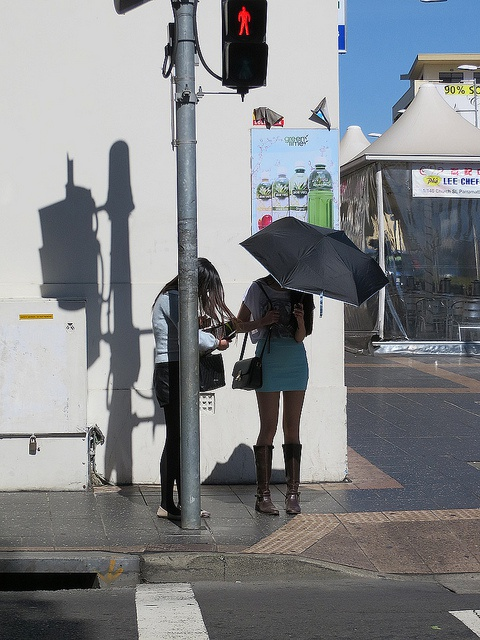Describe the objects in this image and their specific colors. I can see people in lightgray, black, blue, and darkblue tones, people in lightgray, black, gray, and darkgray tones, umbrella in lightgray, black, and gray tones, traffic light in lightgray, black, gray, red, and maroon tones, and handbag in lightgray, black, gray, and darkgray tones in this image. 